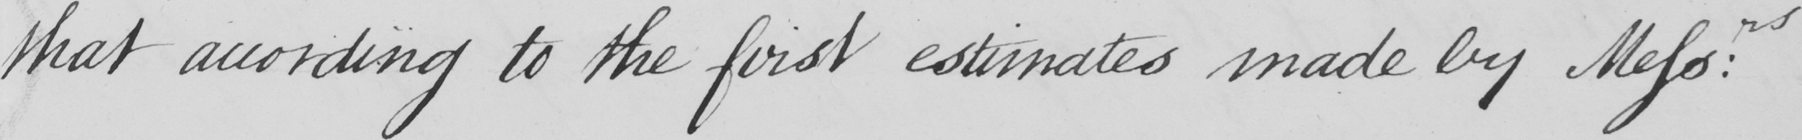Please provide the text content of this handwritten line. that according to the first estimates made by Messrs : 